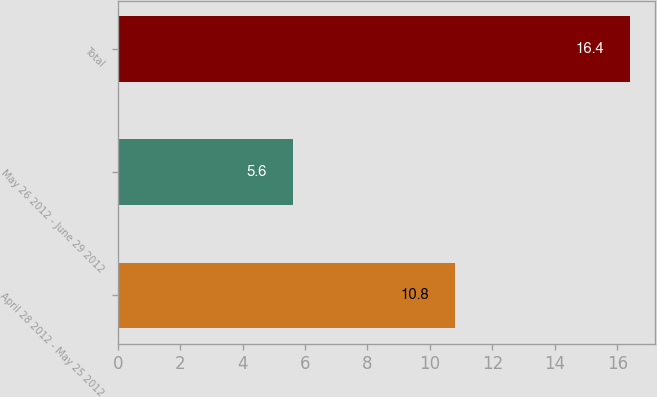Convert chart. <chart><loc_0><loc_0><loc_500><loc_500><bar_chart><fcel>April 28 2012 - May 25 2012<fcel>May 26 2012 - June 29 2012<fcel>Total<nl><fcel>10.8<fcel>5.6<fcel>16.4<nl></chart> 